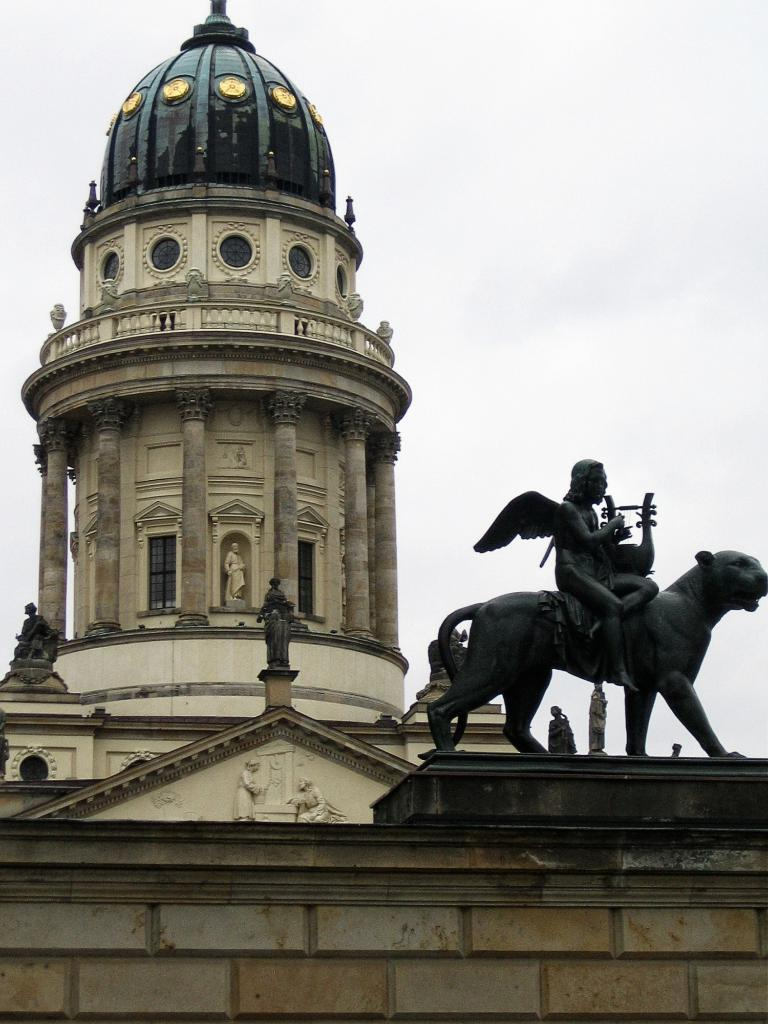What type of structure is visible in the image? There is a building in the image. What architectural feature can be seen on the building? The building has pillars. Are there any other objects or figures in the image besides the building? Yes, there are statues in the image. Can you describe the location of one of the statues in the image? There is a statue on the wall in the foreground of the image. What type of wool is being used to create the order in the image? There is no wool or order present in the image; it features a building with pillars and statues. 